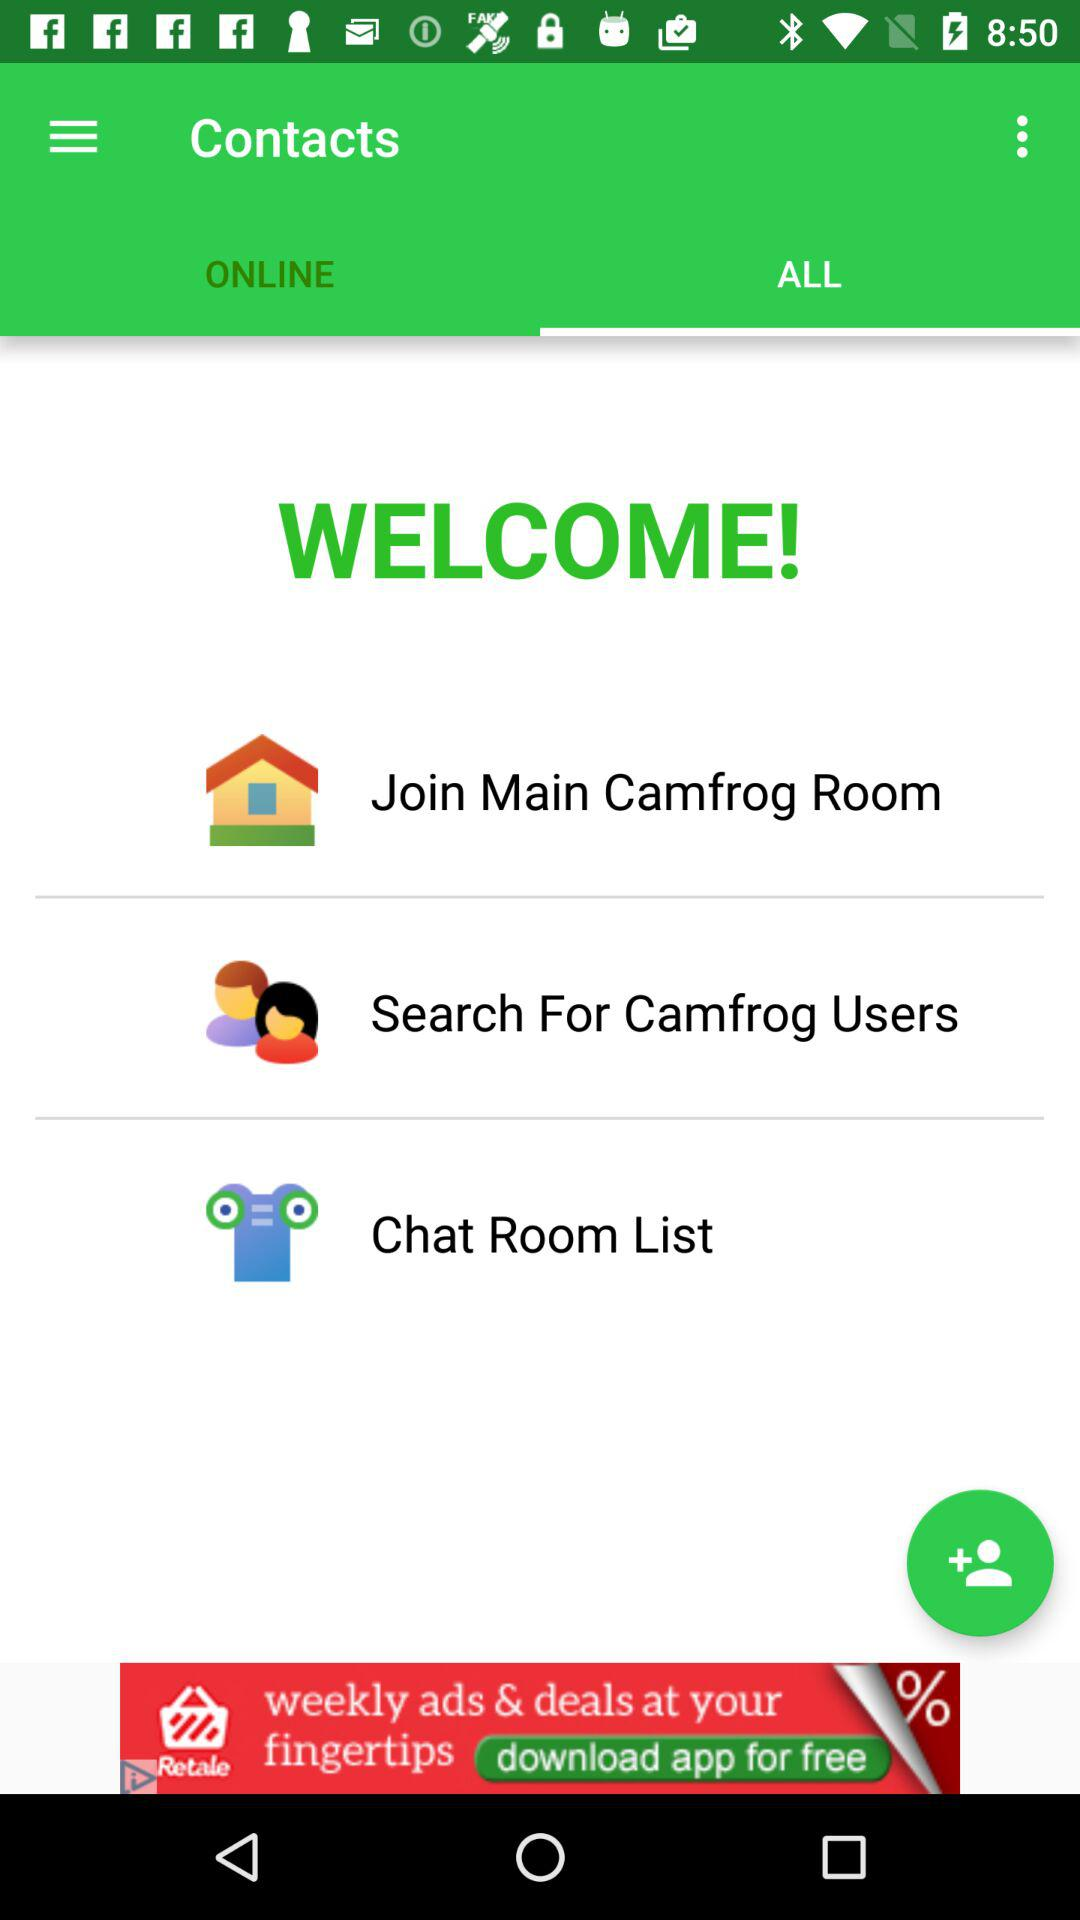Which tab is selected? The selected tab is "ALL". 